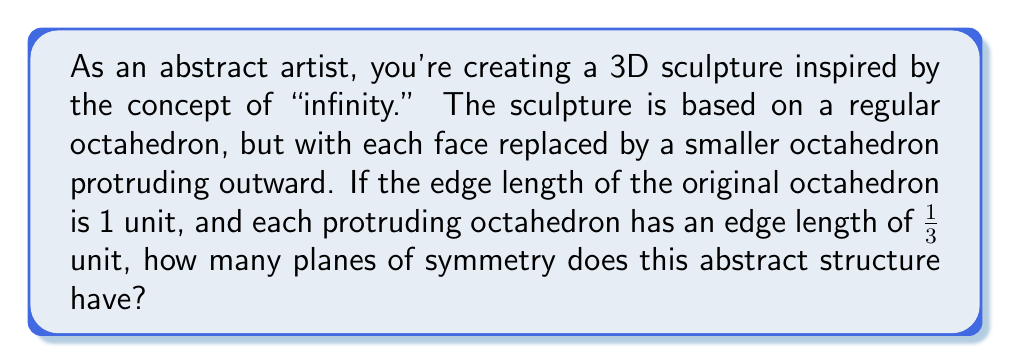Give your solution to this math problem. To solve this problem, let's analyze the symmetry of the structure step by step:

1) First, recall that a regular octahedron has 9 planes of symmetry:
   - 3 planes passing through opposite edges
   - 6 planes passing through opposite vertices

2) Now, let's consider how adding the smaller octahedra affects these symmetry planes:

   a) The 3 planes passing through opposite edges remain planes of symmetry. This is because the smaller octahedra are added uniformly to all faces, preserving the symmetry about these planes.

   b) The 6 planes passing through opposite vertices also remain planes of symmetry for the same reason.

3) The key observation is that adding the smaller octahedra doesn't introduce any new planes of symmetry, nor does it eliminate any existing ones.

4) This is because:
   - The smaller octahedra are all identical and placed in a consistent manner on each face.
   - They maintain the overall symmetry of the original octahedron.

5) Therefore, the number of symmetry planes in the new structure is the same as in a regular octahedron.

To visualize this, we can represent the structure symbolically:

[asy]
import three;

size(200);
currentprojection=perspective(6,3,2);

triple[] vertex={
  (1,1,1),(-1,-1,1),(1,-1,-1),(-1,1,-1),
  (1,-1,1),(-1,1,1),(1,1,-1),(-1,-1,-1)
};

for(int i=0; i<8; ++i)
  vertex[i]=vertex[i]/sqrt(3);

for(int i=0; i<8; ++i)
  dot(vertex[i]);

for(int i=0; i<8; ++i)
  for(int j=i+1; j<8; ++j)
    draw(vertex[i]--vertex[j]);

triple[] center={(1,0,0),(-1,0,0),(0,1,0),(0,-1,0),(0,0,1),(0,0,-1)};

for(int i=0; i<6; ++i) {
  triple[] smallVertex;
  for(int j=0; j<8; ++j)
    smallVertex.push(center[i]+0.2*(vertex[j]-center[i]));
  
  for(int j=0; j<8; ++j)
    for(int k=j+1; k<8; ++k)
      draw(smallVertex[j]--smallVertex[k],blue);
}
[/asy]

This diagram shows the original octahedron (black) with smaller octahedra (blue) protruding from each face.
Answer: The abstract 3D structure has 9 planes of symmetry. 